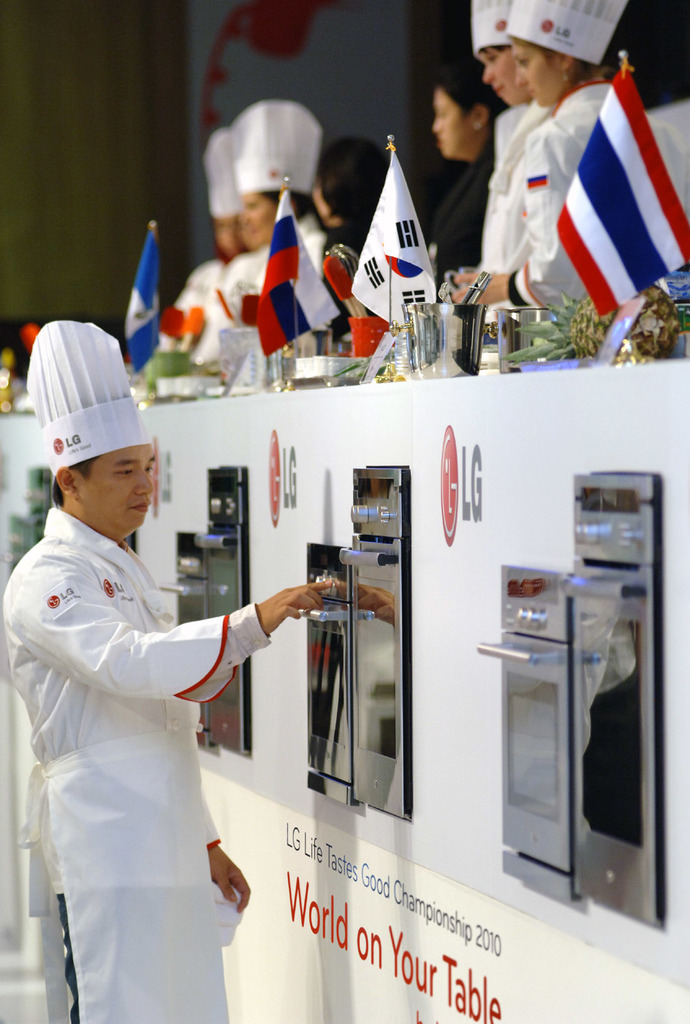Provide a one-sentence caption for the provided image.
Reference OCR token: H, WW, LG, GLie, World, waos, rampionsh, on, Your, Table Several people are at he LG Life Tastes Good Championship in 2010. 